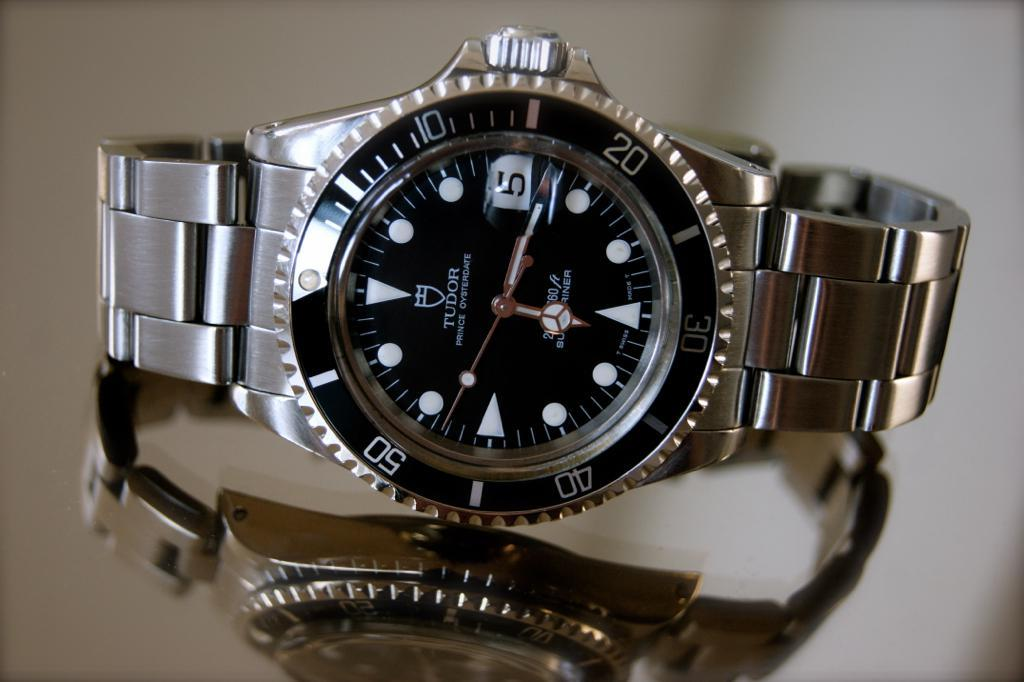<image>
Give a short and clear explanation of the subsequent image. A silver watch says Tudor on the face. 